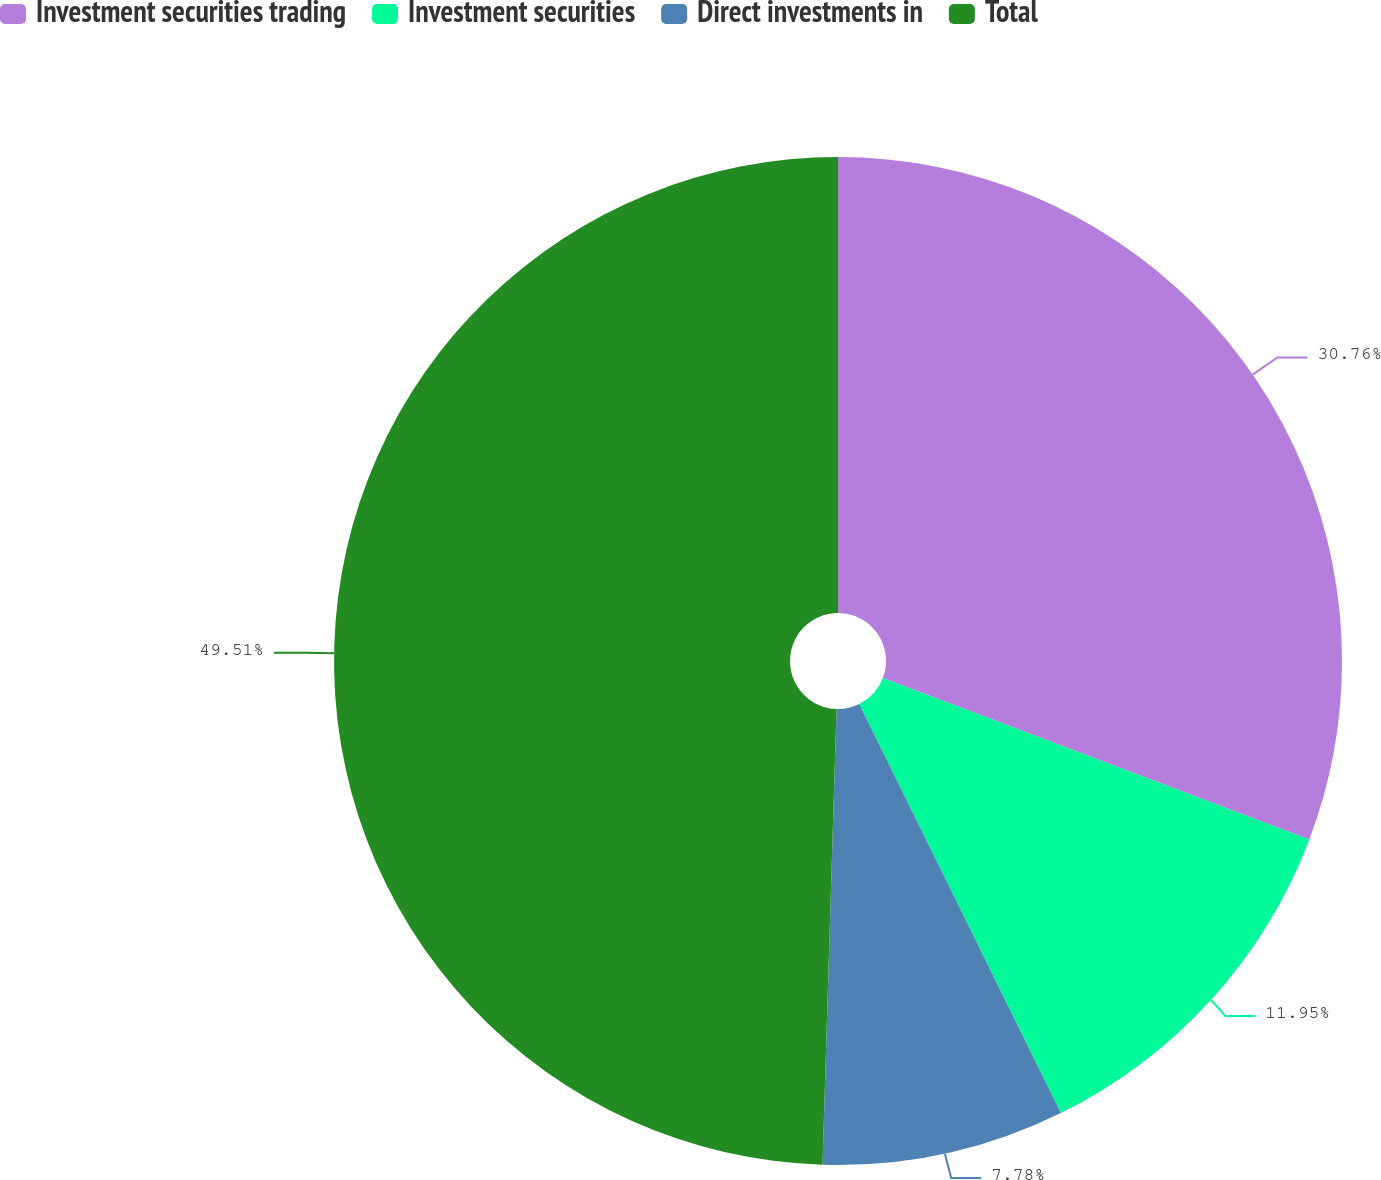Convert chart to OTSL. <chart><loc_0><loc_0><loc_500><loc_500><pie_chart><fcel>Investment securities trading<fcel>Investment securities<fcel>Direct investments in<fcel>Total<nl><fcel>30.76%<fcel>11.95%<fcel>7.78%<fcel>49.51%<nl></chart> 